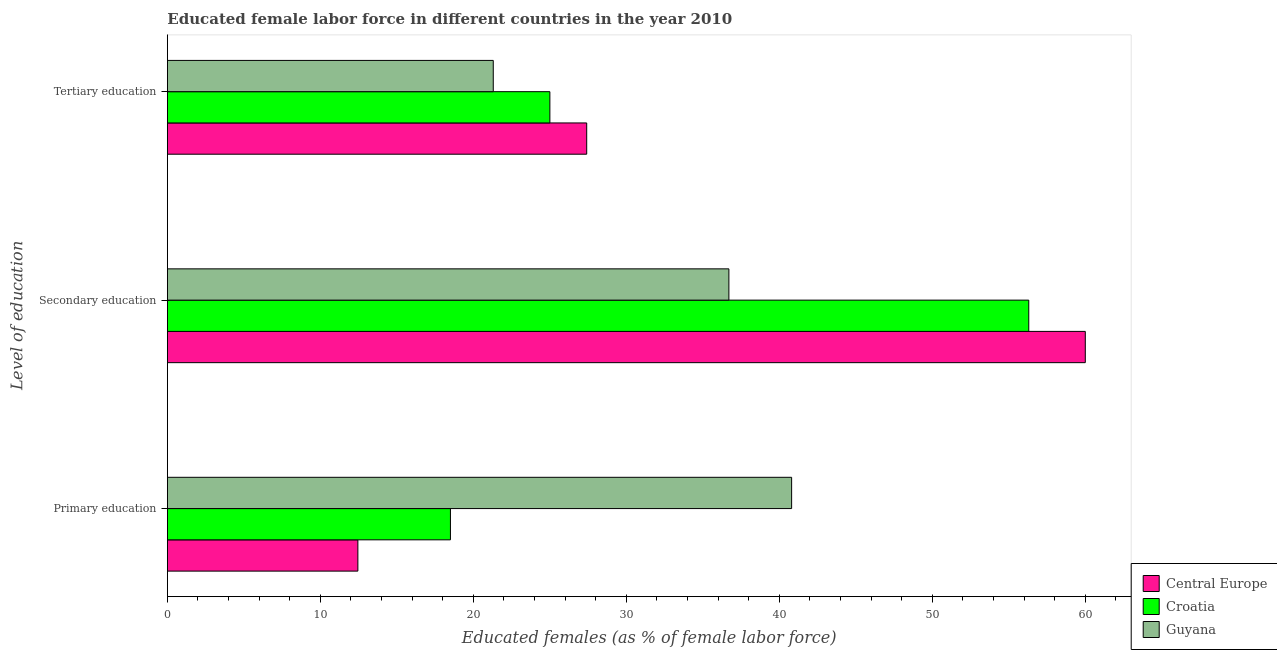How many groups of bars are there?
Give a very brief answer. 3. Are the number of bars on each tick of the Y-axis equal?
Give a very brief answer. Yes. How many bars are there on the 3rd tick from the bottom?
Ensure brevity in your answer.  3. What is the label of the 1st group of bars from the top?
Your answer should be compact. Tertiary education. What is the percentage of female labor force who received primary education in Croatia?
Ensure brevity in your answer.  18.5. Across all countries, what is the maximum percentage of female labor force who received primary education?
Ensure brevity in your answer.  40.8. Across all countries, what is the minimum percentage of female labor force who received tertiary education?
Give a very brief answer. 21.3. In which country was the percentage of female labor force who received tertiary education maximum?
Provide a succinct answer. Central Europe. In which country was the percentage of female labor force who received tertiary education minimum?
Make the answer very short. Guyana. What is the total percentage of female labor force who received secondary education in the graph?
Make the answer very short. 152.99. What is the difference between the percentage of female labor force who received primary education in Guyana and that in Croatia?
Keep it short and to the point. 22.3. What is the difference between the percentage of female labor force who received primary education in Croatia and the percentage of female labor force who received secondary education in Guyana?
Offer a very short reply. -18.2. What is the average percentage of female labor force who received primary education per country?
Keep it short and to the point. 23.92. What is the difference between the percentage of female labor force who received tertiary education and percentage of female labor force who received primary education in Central Europe?
Keep it short and to the point. 14.96. In how many countries, is the percentage of female labor force who received secondary education greater than 14 %?
Offer a very short reply. 3. What is the ratio of the percentage of female labor force who received tertiary education in Guyana to that in Croatia?
Offer a very short reply. 0.85. Is the percentage of female labor force who received primary education in Central Europe less than that in Croatia?
Give a very brief answer. Yes. Is the difference between the percentage of female labor force who received tertiary education in Guyana and Central Europe greater than the difference between the percentage of female labor force who received primary education in Guyana and Central Europe?
Your answer should be compact. No. What is the difference between the highest and the second highest percentage of female labor force who received secondary education?
Your answer should be compact. 3.69. What is the difference between the highest and the lowest percentage of female labor force who received primary education?
Offer a terse response. 28.35. In how many countries, is the percentage of female labor force who received primary education greater than the average percentage of female labor force who received primary education taken over all countries?
Give a very brief answer. 1. What does the 3rd bar from the top in Primary education represents?
Provide a short and direct response. Central Europe. What does the 3rd bar from the bottom in Secondary education represents?
Make the answer very short. Guyana. Are all the bars in the graph horizontal?
Your answer should be compact. Yes. Does the graph contain grids?
Your answer should be compact. No. What is the title of the graph?
Offer a very short reply. Educated female labor force in different countries in the year 2010. Does "Honduras" appear as one of the legend labels in the graph?
Make the answer very short. No. What is the label or title of the X-axis?
Make the answer very short. Educated females (as % of female labor force). What is the label or title of the Y-axis?
Keep it short and to the point. Level of education. What is the Educated females (as % of female labor force) in Central Europe in Primary education?
Your answer should be compact. 12.45. What is the Educated females (as % of female labor force) in Croatia in Primary education?
Make the answer very short. 18.5. What is the Educated females (as % of female labor force) of Guyana in Primary education?
Your answer should be compact. 40.8. What is the Educated females (as % of female labor force) of Central Europe in Secondary education?
Provide a succinct answer. 59.99. What is the Educated females (as % of female labor force) of Croatia in Secondary education?
Offer a very short reply. 56.3. What is the Educated females (as % of female labor force) in Guyana in Secondary education?
Ensure brevity in your answer.  36.7. What is the Educated females (as % of female labor force) in Central Europe in Tertiary education?
Make the answer very short. 27.41. What is the Educated females (as % of female labor force) in Croatia in Tertiary education?
Give a very brief answer. 25. What is the Educated females (as % of female labor force) in Guyana in Tertiary education?
Provide a succinct answer. 21.3. Across all Level of education, what is the maximum Educated females (as % of female labor force) of Central Europe?
Make the answer very short. 59.99. Across all Level of education, what is the maximum Educated females (as % of female labor force) in Croatia?
Give a very brief answer. 56.3. Across all Level of education, what is the maximum Educated females (as % of female labor force) in Guyana?
Your answer should be very brief. 40.8. Across all Level of education, what is the minimum Educated females (as % of female labor force) of Central Europe?
Make the answer very short. 12.45. Across all Level of education, what is the minimum Educated females (as % of female labor force) in Guyana?
Ensure brevity in your answer.  21.3. What is the total Educated females (as % of female labor force) in Central Europe in the graph?
Ensure brevity in your answer.  99.85. What is the total Educated females (as % of female labor force) in Croatia in the graph?
Your answer should be compact. 99.8. What is the total Educated females (as % of female labor force) of Guyana in the graph?
Your answer should be compact. 98.8. What is the difference between the Educated females (as % of female labor force) in Central Europe in Primary education and that in Secondary education?
Keep it short and to the point. -47.54. What is the difference between the Educated females (as % of female labor force) of Croatia in Primary education and that in Secondary education?
Provide a succinct answer. -37.8. What is the difference between the Educated females (as % of female labor force) in Guyana in Primary education and that in Secondary education?
Give a very brief answer. 4.1. What is the difference between the Educated females (as % of female labor force) in Central Europe in Primary education and that in Tertiary education?
Offer a terse response. -14.96. What is the difference between the Educated females (as % of female labor force) in Central Europe in Secondary education and that in Tertiary education?
Provide a succinct answer. 32.59. What is the difference between the Educated females (as % of female labor force) of Croatia in Secondary education and that in Tertiary education?
Provide a short and direct response. 31.3. What is the difference between the Educated females (as % of female labor force) in Guyana in Secondary education and that in Tertiary education?
Provide a short and direct response. 15.4. What is the difference between the Educated females (as % of female labor force) of Central Europe in Primary education and the Educated females (as % of female labor force) of Croatia in Secondary education?
Give a very brief answer. -43.85. What is the difference between the Educated females (as % of female labor force) of Central Europe in Primary education and the Educated females (as % of female labor force) of Guyana in Secondary education?
Ensure brevity in your answer.  -24.25. What is the difference between the Educated females (as % of female labor force) of Croatia in Primary education and the Educated females (as % of female labor force) of Guyana in Secondary education?
Ensure brevity in your answer.  -18.2. What is the difference between the Educated females (as % of female labor force) of Central Europe in Primary education and the Educated females (as % of female labor force) of Croatia in Tertiary education?
Keep it short and to the point. -12.55. What is the difference between the Educated females (as % of female labor force) in Central Europe in Primary education and the Educated females (as % of female labor force) in Guyana in Tertiary education?
Ensure brevity in your answer.  -8.85. What is the difference between the Educated females (as % of female labor force) in Croatia in Primary education and the Educated females (as % of female labor force) in Guyana in Tertiary education?
Offer a very short reply. -2.8. What is the difference between the Educated females (as % of female labor force) in Central Europe in Secondary education and the Educated females (as % of female labor force) in Croatia in Tertiary education?
Your response must be concise. 34.99. What is the difference between the Educated females (as % of female labor force) of Central Europe in Secondary education and the Educated females (as % of female labor force) of Guyana in Tertiary education?
Ensure brevity in your answer.  38.69. What is the average Educated females (as % of female labor force) of Central Europe per Level of education?
Make the answer very short. 33.28. What is the average Educated females (as % of female labor force) of Croatia per Level of education?
Give a very brief answer. 33.27. What is the average Educated females (as % of female labor force) in Guyana per Level of education?
Provide a succinct answer. 32.93. What is the difference between the Educated females (as % of female labor force) of Central Europe and Educated females (as % of female labor force) of Croatia in Primary education?
Your answer should be very brief. -6.05. What is the difference between the Educated females (as % of female labor force) of Central Europe and Educated females (as % of female labor force) of Guyana in Primary education?
Ensure brevity in your answer.  -28.35. What is the difference between the Educated females (as % of female labor force) in Croatia and Educated females (as % of female labor force) in Guyana in Primary education?
Provide a short and direct response. -22.3. What is the difference between the Educated females (as % of female labor force) of Central Europe and Educated females (as % of female labor force) of Croatia in Secondary education?
Provide a succinct answer. 3.69. What is the difference between the Educated females (as % of female labor force) in Central Europe and Educated females (as % of female labor force) in Guyana in Secondary education?
Your response must be concise. 23.29. What is the difference between the Educated females (as % of female labor force) of Croatia and Educated females (as % of female labor force) of Guyana in Secondary education?
Provide a short and direct response. 19.6. What is the difference between the Educated females (as % of female labor force) in Central Europe and Educated females (as % of female labor force) in Croatia in Tertiary education?
Offer a terse response. 2.41. What is the difference between the Educated females (as % of female labor force) of Central Europe and Educated females (as % of female labor force) of Guyana in Tertiary education?
Offer a very short reply. 6.11. What is the ratio of the Educated females (as % of female labor force) of Central Europe in Primary education to that in Secondary education?
Keep it short and to the point. 0.21. What is the ratio of the Educated females (as % of female labor force) of Croatia in Primary education to that in Secondary education?
Provide a succinct answer. 0.33. What is the ratio of the Educated females (as % of female labor force) in Guyana in Primary education to that in Secondary education?
Your response must be concise. 1.11. What is the ratio of the Educated females (as % of female labor force) of Central Europe in Primary education to that in Tertiary education?
Your response must be concise. 0.45. What is the ratio of the Educated females (as % of female labor force) of Croatia in Primary education to that in Tertiary education?
Keep it short and to the point. 0.74. What is the ratio of the Educated females (as % of female labor force) of Guyana in Primary education to that in Tertiary education?
Keep it short and to the point. 1.92. What is the ratio of the Educated females (as % of female labor force) in Central Europe in Secondary education to that in Tertiary education?
Keep it short and to the point. 2.19. What is the ratio of the Educated females (as % of female labor force) of Croatia in Secondary education to that in Tertiary education?
Provide a succinct answer. 2.25. What is the ratio of the Educated females (as % of female labor force) of Guyana in Secondary education to that in Tertiary education?
Offer a terse response. 1.72. What is the difference between the highest and the second highest Educated females (as % of female labor force) of Central Europe?
Your response must be concise. 32.59. What is the difference between the highest and the second highest Educated females (as % of female labor force) of Croatia?
Make the answer very short. 31.3. What is the difference between the highest and the second highest Educated females (as % of female labor force) of Guyana?
Keep it short and to the point. 4.1. What is the difference between the highest and the lowest Educated females (as % of female labor force) of Central Europe?
Ensure brevity in your answer.  47.54. What is the difference between the highest and the lowest Educated females (as % of female labor force) in Croatia?
Keep it short and to the point. 37.8. What is the difference between the highest and the lowest Educated females (as % of female labor force) of Guyana?
Provide a short and direct response. 19.5. 